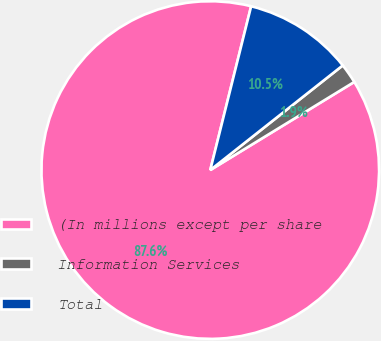Convert chart. <chart><loc_0><loc_0><loc_500><loc_500><pie_chart><fcel>(In millions except per share<fcel>Information Services<fcel>Total<nl><fcel>87.63%<fcel>1.9%<fcel>10.47%<nl></chart> 